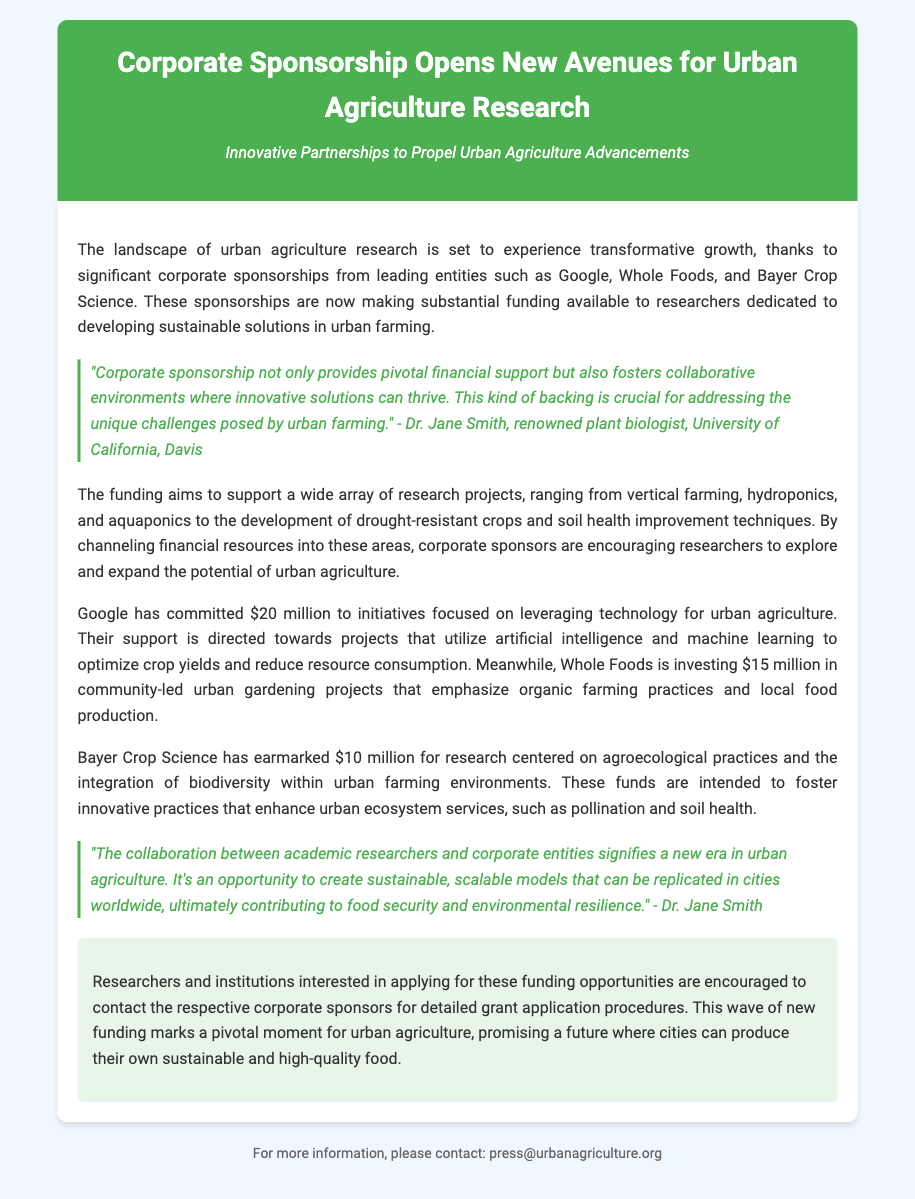What companies are sponsoring urban agriculture research? The document mentions Google, Whole Foods, and Bayer Crop Science as the leading entities providing corporate sponsorships.
Answer: Google, Whole Foods, Bayer Crop Science How much funding has Google committed to urban agriculture initiatives? According to the document, Google has committed $20 million towards urban agriculture initiatives.
Answer: $20 million What type of projects is Whole Foods funding? Whole Foods is investing $15 million in community-led urban gardening projects that emphasize organic farming practices and local food production.
Answer: Community-led urban gardening projects What is the total amount of funding provided by the three companies mentioned? The total funding from Google ($20 million), Whole Foods ($15 million), and Bayer Crop Science ($10 million) is $45 million.
Answer: $45 million What is a key focus area of Bayer Crop Science's funding? The document states that Bayer Crop Science's funding is centered on agroecological practices and the integration of biodiversity within urban farming environments.
Answer: Agroecological practices What is the role of corporate sponsorship, according to Dr. Jane Smith? Dr. Jane Smith states that corporate sponsorship provides pivotal financial support and fosters collaborative environments for innovative solutions.
Answer: Pivotal financial support What does the funding aim to support? The funding aims to support research projects including vertical farming, hydroponics, aquaponics, drought-resistant crops, and soil health improvement techniques.
Answer: Research projects including vertical farming, hydroponics, aquaponics Who should interested researchers contact for grant application procedures? The conclusion of the document encourages researchers and institutions to contact the respective corporate sponsors for detailed grant application procedures.
Answer: Corporate sponsors 